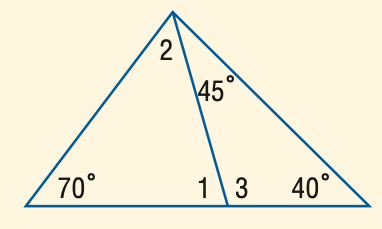Answer the mathemtical geometry problem and directly provide the correct option letter.
Question: Find the measure of \angle 1.
Choices: A: 70 B: 75 C: 80 D: 85 D 